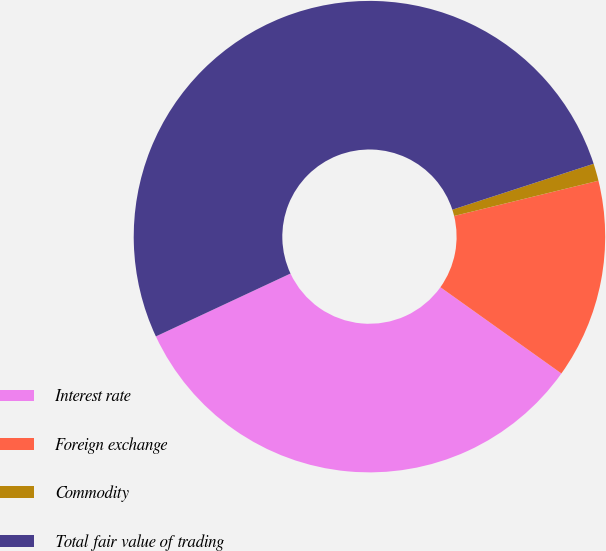Convert chart. <chart><loc_0><loc_0><loc_500><loc_500><pie_chart><fcel>Interest rate<fcel>Foreign exchange<fcel>Commodity<fcel>Total fair value of trading<nl><fcel>33.19%<fcel>13.67%<fcel>1.19%<fcel>51.96%<nl></chart> 